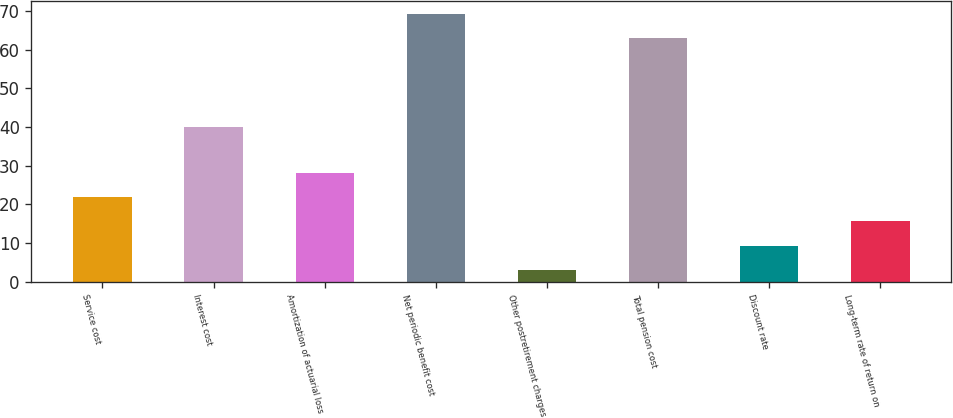Convert chart. <chart><loc_0><loc_0><loc_500><loc_500><bar_chart><fcel>Service cost<fcel>Interest cost<fcel>Amortization of actuarial loss<fcel>Net periodic benefit cost<fcel>Other postretirement charges<fcel>Total pension cost<fcel>Discount rate<fcel>Long-term rate of return on<nl><fcel>21.9<fcel>40<fcel>28.2<fcel>69.3<fcel>3<fcel>63<fcel>9.3<fcel>15.6<nl></chart> 